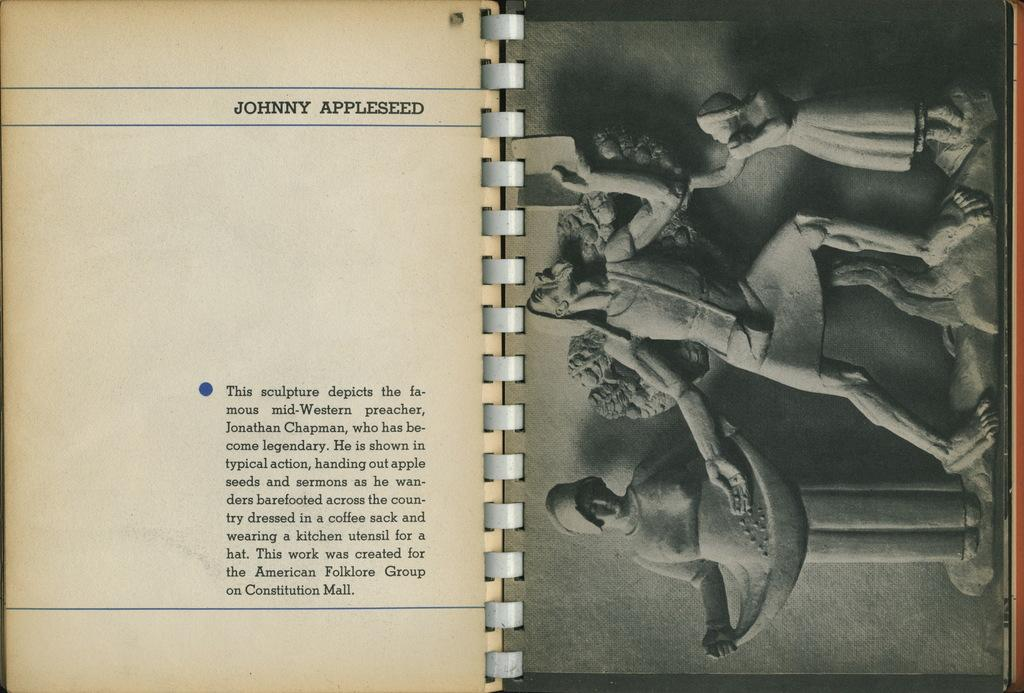What is depicted on the pages of the book in the image? There are statues on the pages of the book. What else can be seen on the pages of the book? There is some text visible on the pages of the book. Can you describe the type of text visible on the pages of the book? Unfortunately, the facts provided do not give enough information to describe the type of text visible on the pages of the book. What type of carriage can be seen in the image? There is no carriage present in the image. What noise can be heard coming from the statues in the image? There is no noise present in the image, as it is a static image of a book with statues on its pages. 